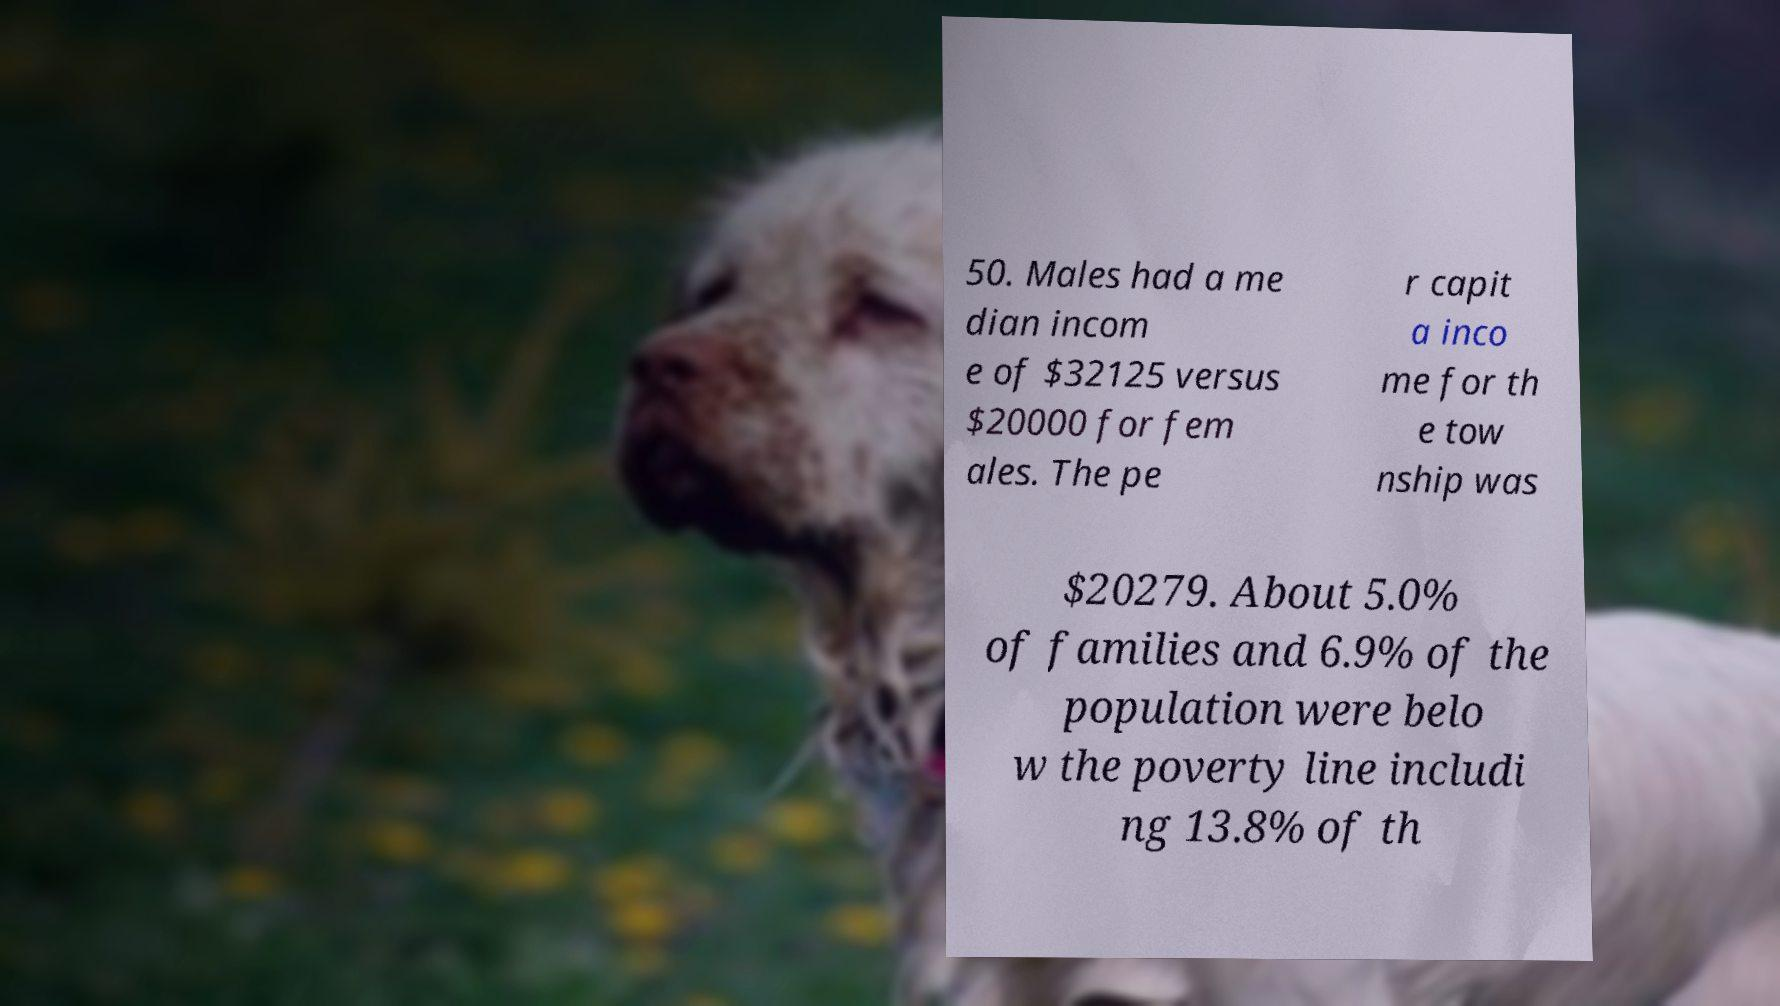Please identify and transcribe the text found in this image. 50. Males had a me dian incom e of $32125 versus $20000 for fem ales. The pe r capit a inco me for th e tow nship was $20279. About 5.0% of families and 6.9% of the population were belo w the poverty line includi ng 13.8% of th 